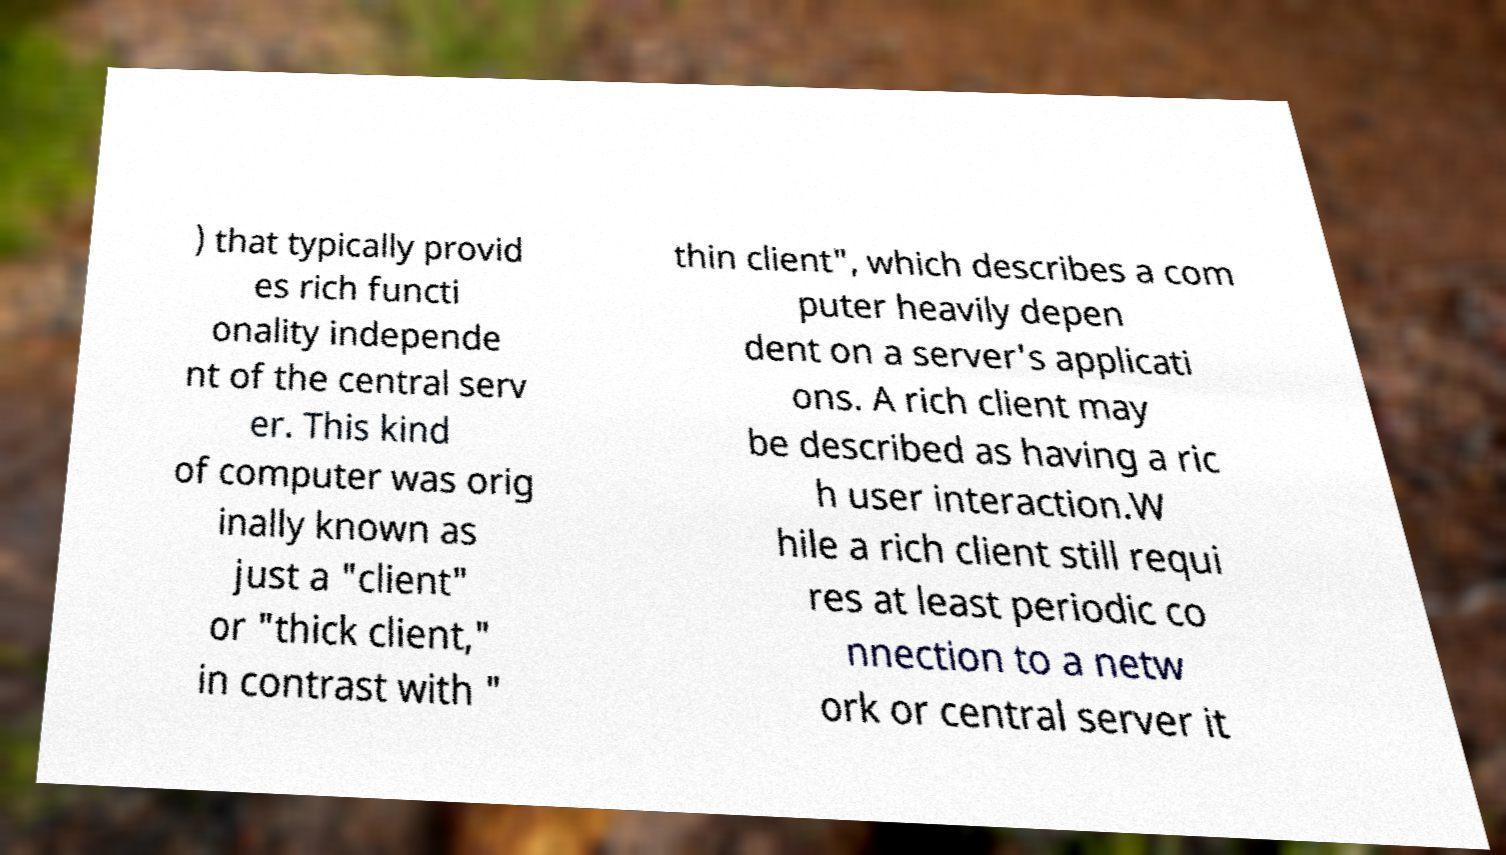Can you accurately transcribe the text from the provided image for me? ) that typically provid es rich functi onality independe nt of the central serv er. This kind of computer was orig inally known as just a "client" or "thick client," in contrast with " thin client", which describes a com puter heavily depen dent on a server's applicati ons. A rich client may be described as having a ric h user interaction.W hile a rich client still requi res at least periodic co nnection to a netw ork or central server it 